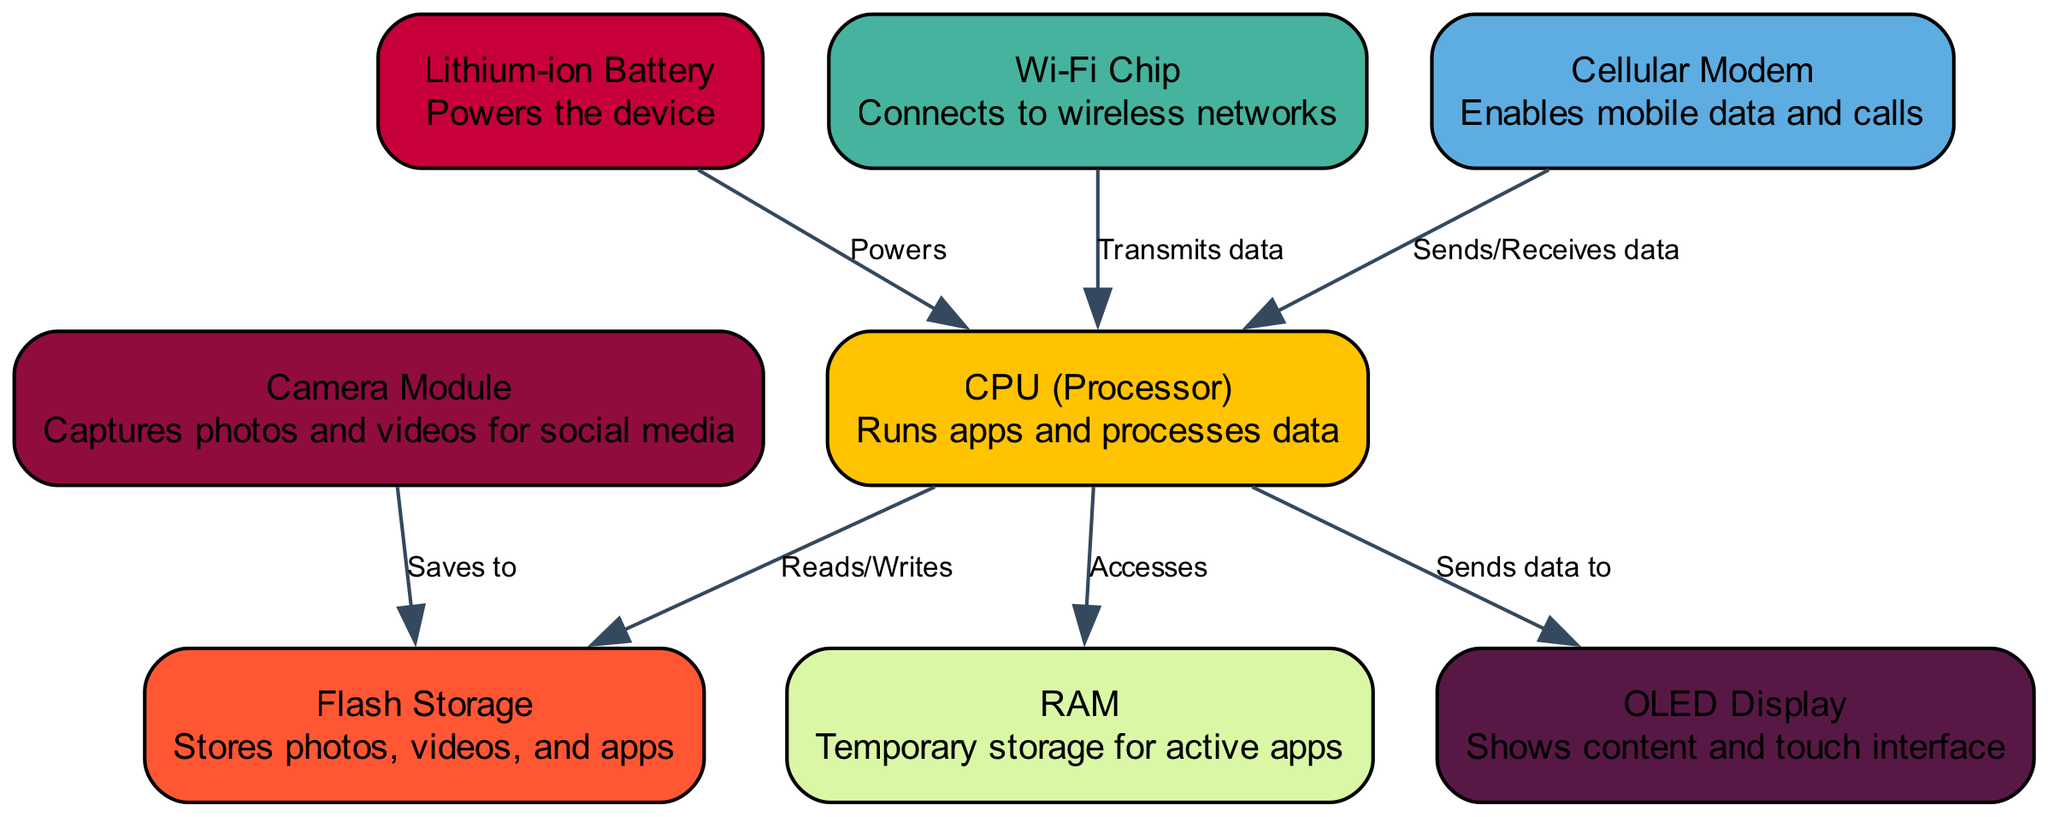What component runs apps and processes data? The diagram clearly labels the CPU (Processor) as the component responsible for running apps and processing data. Thus, by identifying the node labeled "CPU (Processor)", we can answer this question directly.
Answer: CPU (Processor) How many nodes are there in the diagram? By counting the nodes present in the diagram, we find a total of eight distinct components such as CPU, RAM, Flash Storage, and others. This total includes all labeled internal components.
Answer: 8 Which component saves media such as photos and videos? The diagram shows that the Camera Module is connected with an edge labeled "Saves to" pointing towards Flash Storage. Therefore, the Camera Module is responsible for saving media.
Answer: Camera Module What does the Lithium-ion Battery power? Looking at the directed edges, the Lithium-ion Battery has an edge labeled "Powers" directed to the CPU (Processor). This shows that it supplies power to this specific component, completing the relationship.
Answer: CPU (Processor) What two types of network connections are represented in the diagram? The diagram includes a Wi-Fi Chip and a Cellular Modem, both of which are nodes that enable network connections. The explicit labeling of these components makes the answer clear as they are designed for wireless connections.
Answer: Wi-Fi Chip and Cellular Modem Which component accesses RAM? Based on the edges in the diagram, the CPU (Processor) has a directed edge labeled "Accesses" that goes to the RAM node. This indicates that the CPU retrieves or processes information from RAM.
Answer: CPU (Processor) What does the OLED Display show? The OLED Display node is described in the diagram as "Shows content and touch interface” indicating that it presents various visual information and responds to user input through touch.
Answer: Content and touch interface How many edges are present that indicate the flow of data? By systematically counting the edges connecting the nodes in the diagram, we identify a total of seven edges representing the flow of data between various components, showcasing their interactions.
Answer: 7 